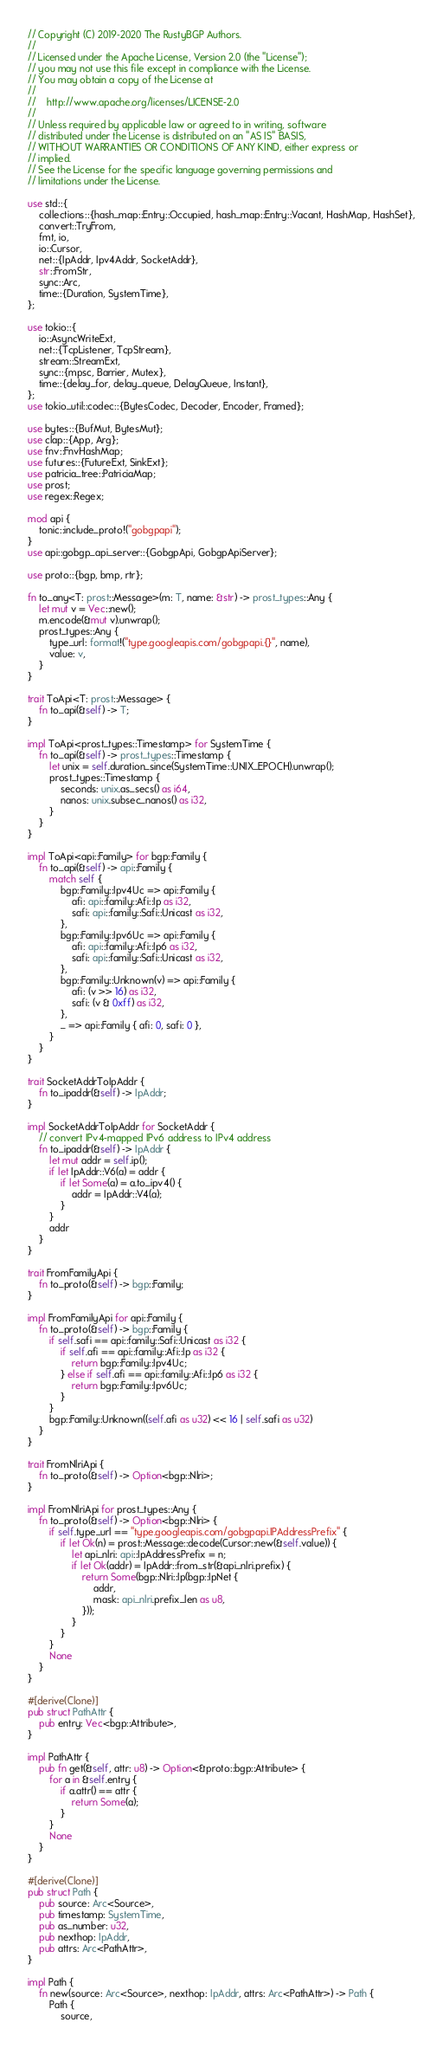<code> <loc_0><loc_0><loc_500><loc_500><_Rust_>// Copyright (C) 2019-2020 The RustyBGP Authors.
//
// Licensed under the Apache License, Version 2.0 (the "License");
// you may not use this file except in compliance with the License.
// You may obtain a copy of the License at
//
//    http://www.apache.org/licenses/LICENSE-2.0
//
// Unless required by applicable law or agreed to in writing, software
// distributed under the License is distributed on an "AS IS" BASIS,
// WITHOUT WARRANTIES OR CONDITIONS OF ANY KIND, either express or
// implied.
// See the License for the specific language governing permissions and
// limitations under the License.

use std::{
    collections::{hash_map::Entry::Occupied, hash_map::Entry::Vacant, HashMap, HashSet},
    convert::TryFrom,
    fmt, io,
    io::Cursor,
    net::{IpAddr, Ipv4Addr, SocketAddr},
    str::FromStr,
    sync::Arc,
    time::{Duration, SystemTime},
};

use tokio::{
    io::AsyncWriteExt,
    net::{TcpListener, TcpStream},
    stream::StreamExt,
    sync::{mpsc, Barrier, Mutex},
    time::{delay_for, delay_queue, DelayQueue, Instant},
};
use tokio_util::codec::{BytesCodec, Decoder, Encoder, Framed};

use bytes::{BufMut, BytesMut};
use clap::{App, Arg};
use fnv::FnvHashMap;
use futures::{FutureExt, SinkExt};
use patricia_tree::PatriciaMap;
use prost;
use regex::Regex;

mod api {
    tonic::include_proto!("gobgpapi");
}
use api::gobgp_api_server::{GobgpApi, GobgpApiServer};

use proto::{bgp, bmp, rtr};

fn to_any<T: prost::Message>(m: T, name: &str) -> prost_types::Any {
    let mut v = Vec::new();
    m.encode(&mut v).unwrap();
    prost_types::Any {
        type_url: format!("type.googleapis.com/gobgpapi.{}", name),
        value: v,
    }
}

trait ToApi<T: prost::Message> {
    fn to_api(&self) -> T;
}

impl ToApi<prost_types::Timestamp> for SystemTime {
    fn to_api(&self) -> prost_types::Timestamp {
        let unix = self.duration_since(SystemTime::UNIX_EPOCH).unwrap();
        prost_types::Timestamp {
            seconds: unix.as_secs() as i64,
            nanos: unix.subsec_nanos() as i32,
        }
    }
}

impl ToApi<api::Family> for bgp::Family {
    fn to_api(&self) -> api::Family {
        match self {
            bgp::Family::Ipv4Uc => api::Family {
                afi: api::family::Afi::Ip as i32,
                safi: api::family::Safi::Unicast as i32,
            },
            bgp::Family::Ipv6Uc => api::Family {
                afi: api::family::Afi::Ip6 as i32,
                safi: api::family::Safi::Unicast as i32,
            },
            bgp::Family::Unknown(v) => api::Family {
                afi: (v >> 16) as i32,
                safi: (v & 0xff) as i32,
            },
            _ => api::Family { afi: 0, safi: 0 },
        }
    }
}

trait SocketAddrToIpAddr {
    fn to_ipaddr(&self) -> IpAddr;
}

impl SocketAddrToIpAddr for SocketAddr {
    // convert IPv4-mapped IPv6 address to IPv4 address
    fn to_ipaddr(&self) -> IpAddr {
        let mut addr = self.ip();
        if let IpAddr::V6(a) = addr {
            if let Some(a) = a.to_ipv4() {
                addr = IpAddr::V4(a);
            }
        }
        addr
    }
}

trait FromFamilyApi {
    fn to_proto(&self) -> bgp::Family;
}

impl FromFamilyApi for api::Family {
    fn to_proto(&self) -> bgp::Family {
        if self.safi == api::family::Safi::Unicast as i32 {
            if self.afi == api::family::Afi::Ip as i32 {
                return bgp::Family::Ipv4Uc;
            } else if self.afi == api::family::Afi::Ip6 as i32 {
                return bgp::Family::Ipv6Uc;
            }
        }
        bgp::Family::Unknown((self.afi as u32) << 16 | self.safi as u32)
    }
}

trait FromNlriApi {
    fn to_proto(&self) -> Option<bgp::Nlri>;
}

impl FromNlriApi for prost_types::Any {
    fn to_proto(&self) -> Option<bgp::Nlri> {
        if self.type_url == "type.googleapis.com/gobgpapi.IPAddressPrefix" {
            if let Ok(n) = prost::Message::decode(Cursor::new(&self.value)) {
                let api_nlri: api::IpAddressPrefix = n;
                if let Ok(addr) = IpAddr::from_str(&api_nlri.prefix) {
                    return Some(bgp::Nlri::Ip(bgp::IpNet {
                        addr,
                        mask: api_nlri.prefix_len as u8,
                    }));
                }
            }
        }
        None
    }
}

#[derive(Clone)]
pub struct PathAttr {
    pub entry: Vec<bgp::Attribute>,
}

impl PathAttr {
    pub fn get(&self, attr: u8) -> Option<&proto::bgp::Attribute> {
        for a in &self.entry {
            if a.attr() == attr {
                return Some(a);
            }
        }
        None
    }
}

#[derive(Clone)]
pub struct Path {
    pub source: Arc<Source>,
    pub timestamp: SystemTime,
    pub as_number: u32,
    pub nexthop: IpAddr,
    pub attrs: Arc<PathAttr>,
}

impl Path {
    fn new(source: Arc<Source>, nexthop: IpAddr, attrs: Arc<PathAttr>) -> Path {
        Path {
            source,</code> 